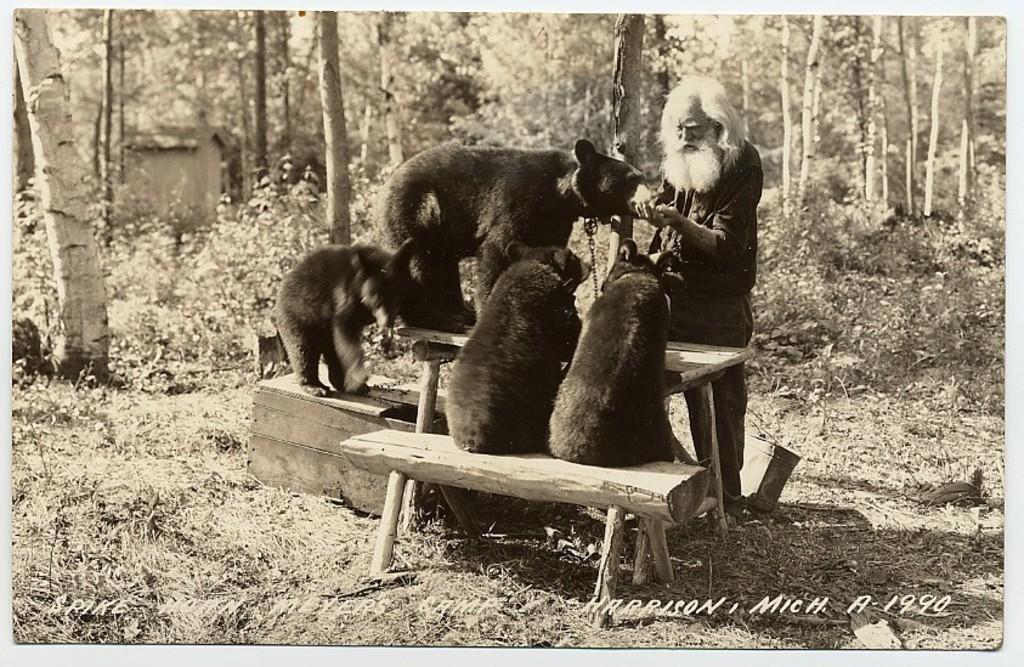Describe this image in one or two sentences. This is a black and white image. In the center of the image we can see a table, bench and a box. We can see some bears are sitting and standing, beside that a man is standing and feeding a bear. In the background of the image we can see a house, trees and some plants. At the bottom of the image we can see some text and ground. 